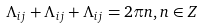Convert formula to latex. <formula><loc_0><loc_0><loc_500><loc_500>\Lambda _ { i j } + \Lambda _ { i j } + \Lambda _ { i j } = 2 \pi n , n \in Z</formula> 